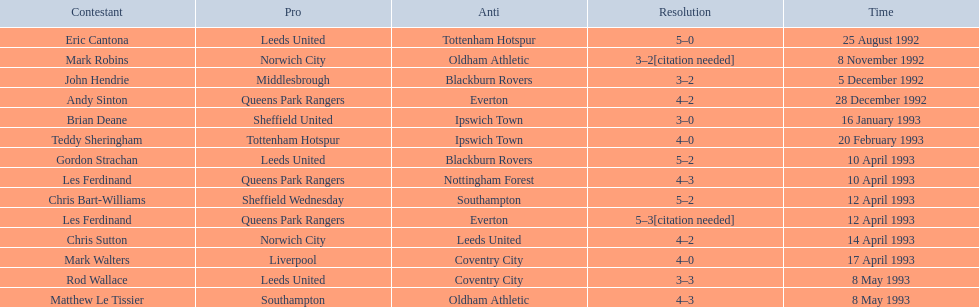Which team did liverpool play against? Coventry City. 